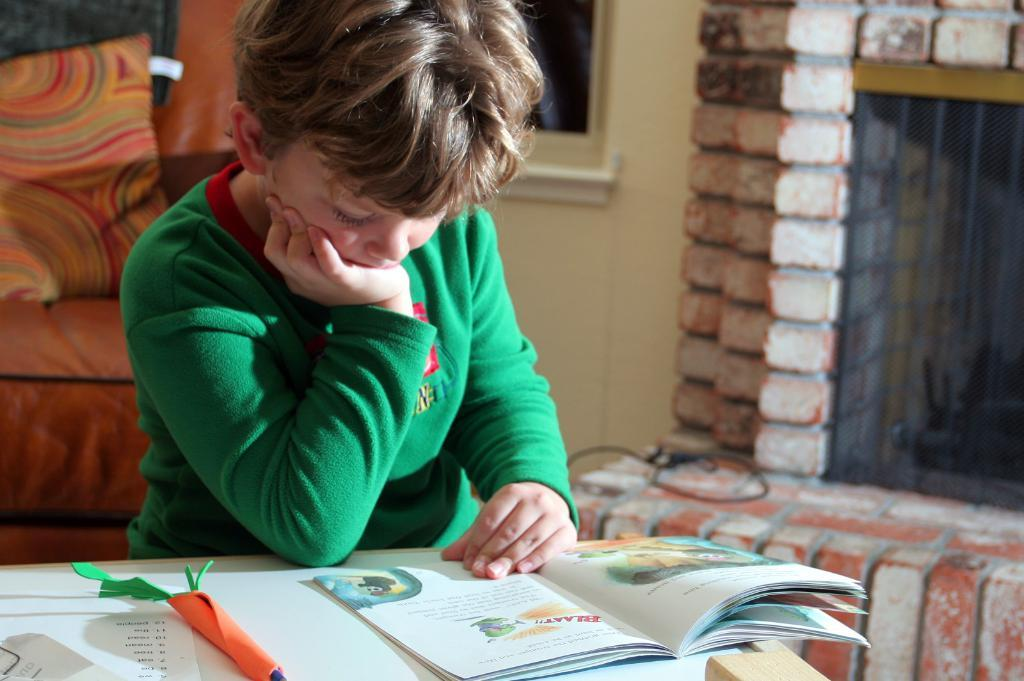<image>
Present a compact description of the photo's key features. a boy reading a book that has the word 'blaat!!' in it 